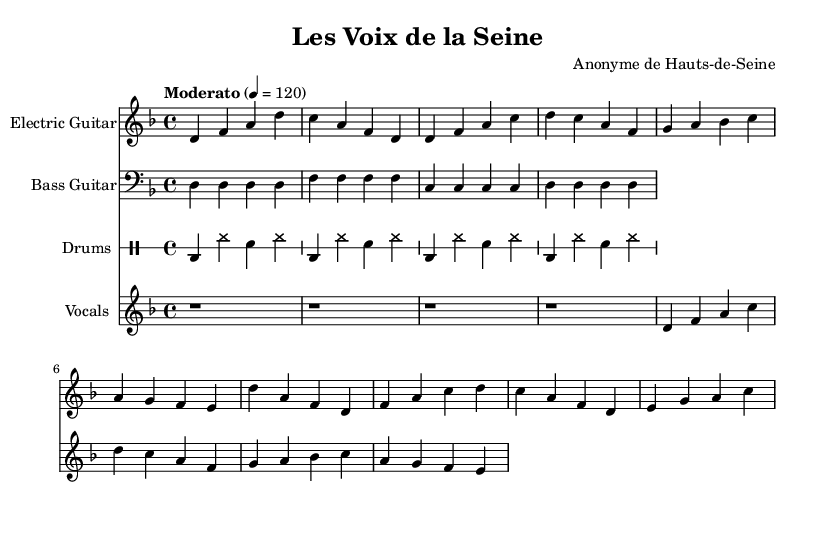What is the key signature of this music? The key signature is D minor, which contains one flat (B flat). This is determined by looking at the key signature indicated in the staff at the beginning of the score.
Answer: D minor What is the time signature of this piece? The time signature is 4/4, which means there are four beats in a measure and the quarter note gets one beat. This can be found at the beginning of the score next to the key signature.
Answer: 4/4 What is the tempo marking for this music? The tempo marking is "Moderato" at 120 beats per minute. This is stated in the tempo instruction at the beginning of the score, providing guidance on the speed at which the piece should be played.
Answer: Moderato How many measures are in the vocal part? The vocal part has four measures. By counting the horizontal lines in the vocal staff, each set of notes separated by vertical lines represents one measure.
Answer: Four What instruments are featured in this piece? The instruments featured are electric guitar, bass guitar, drums, and vocals. This is indicated at the start of each staff, where the instrument names are explicitly written.
Answer: Electric guitar, bass guitar, drums, vocals What motif is highlighted in the lyrics? The motif highlighted is voices rising in the streets, representing a theme of social awareness and activism. This is derived from the textual context of the lyrics, which speaks to listening to the voices of the people.
Answer: Voices rising 